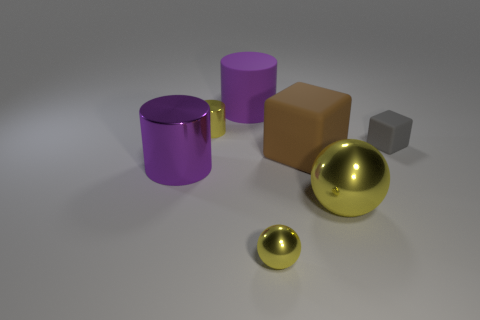Subtract all small yellow metal cylinders. How many cylinders are left? 2 Add 2 small yellow matte objects. How many objects exist? 9 Subtract all blue cubes. How many purple cylinders are left? 2 Subtract 1 cylinders. How many cylinders are left? 2 Subtract all yellow cylinders. How many cylinders are left? 2 Subtract all blocks. How many objects are left? 5 Subtract all red spheres. Subtract all purple cylinders. How many spheres are left? 2 Subtract all large yellow cylinders. Subtract all tiny yellow shiny things. How many objects are left? 5 Add 3 large metallic spheres. How many large metallic spheres are left? 4 Add 1 tiny red cubes. How many tiny red cubes exist? 1 